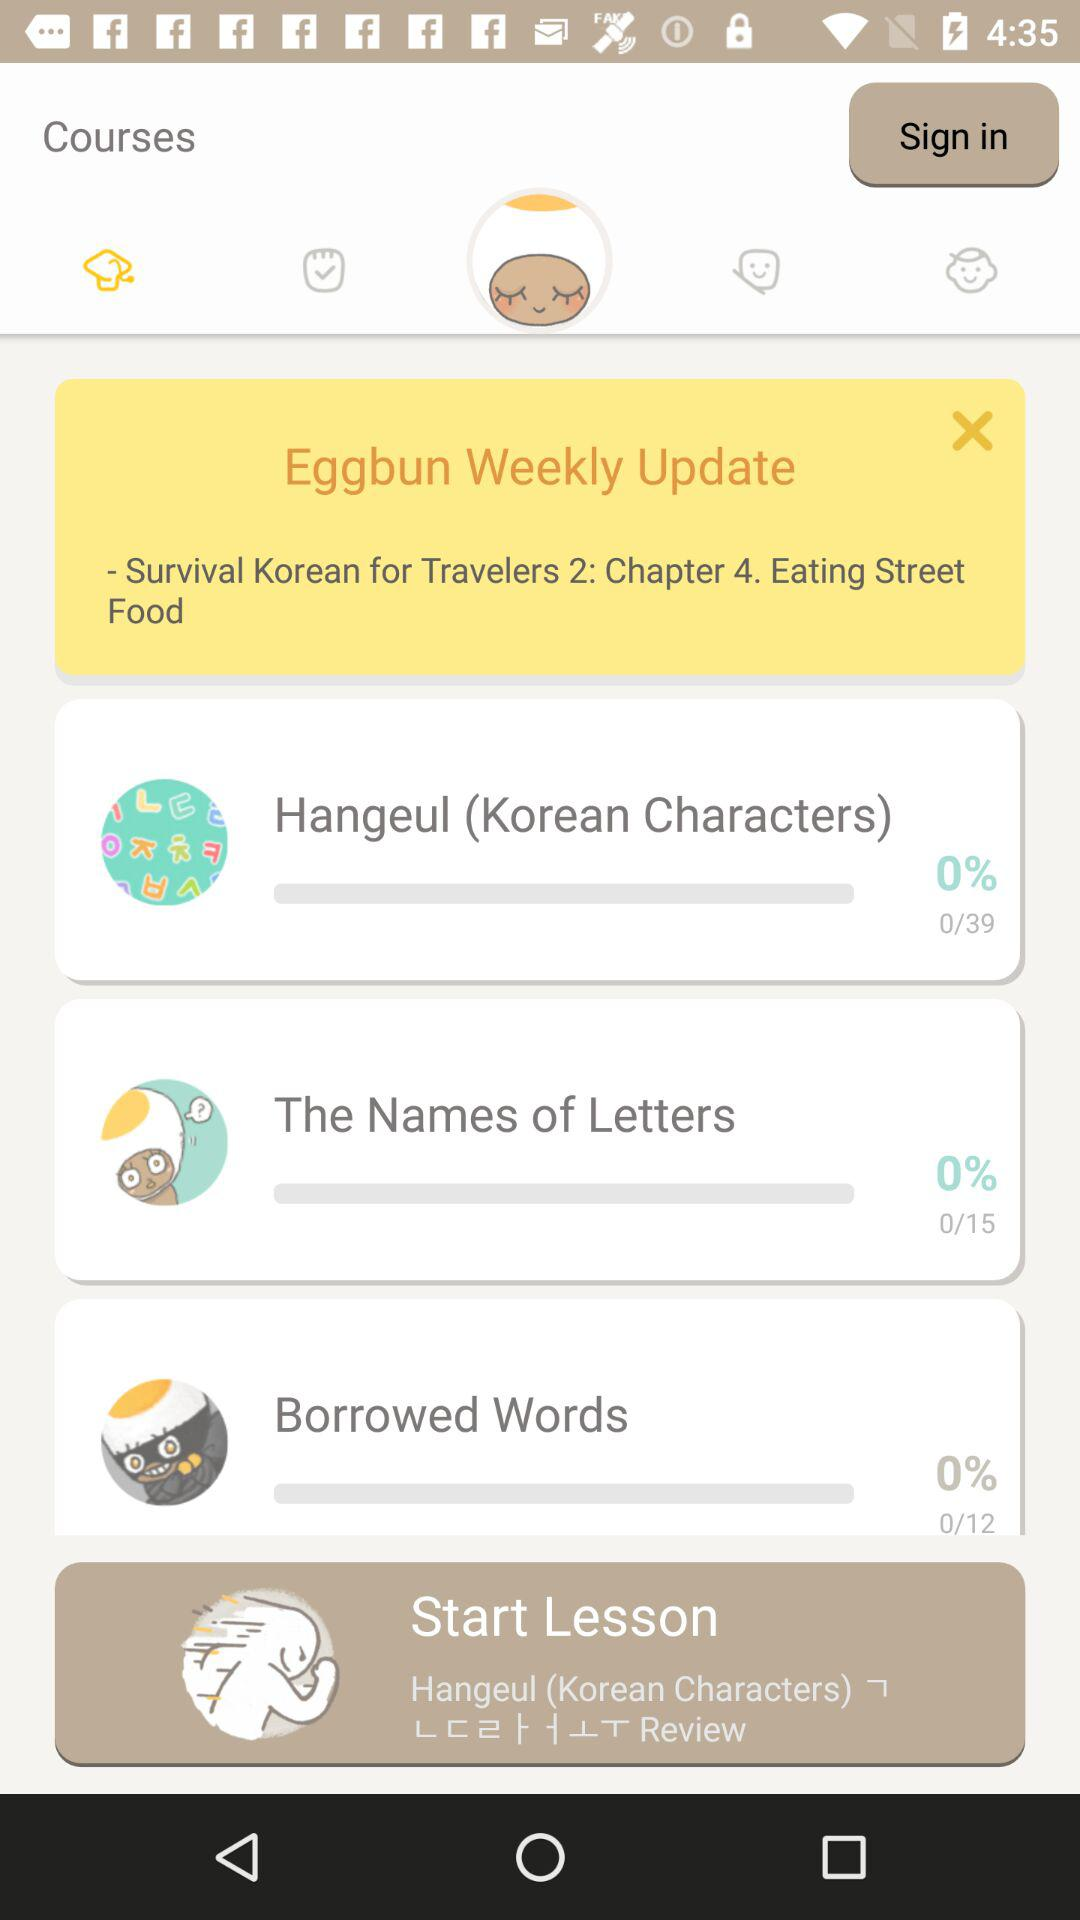What is the chapter name? The chapter name is Eating Street Food. 